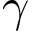Convert formula to latex. <formula><loc_0><loc_0><loc_500><loc_500>\gamma</formula> 